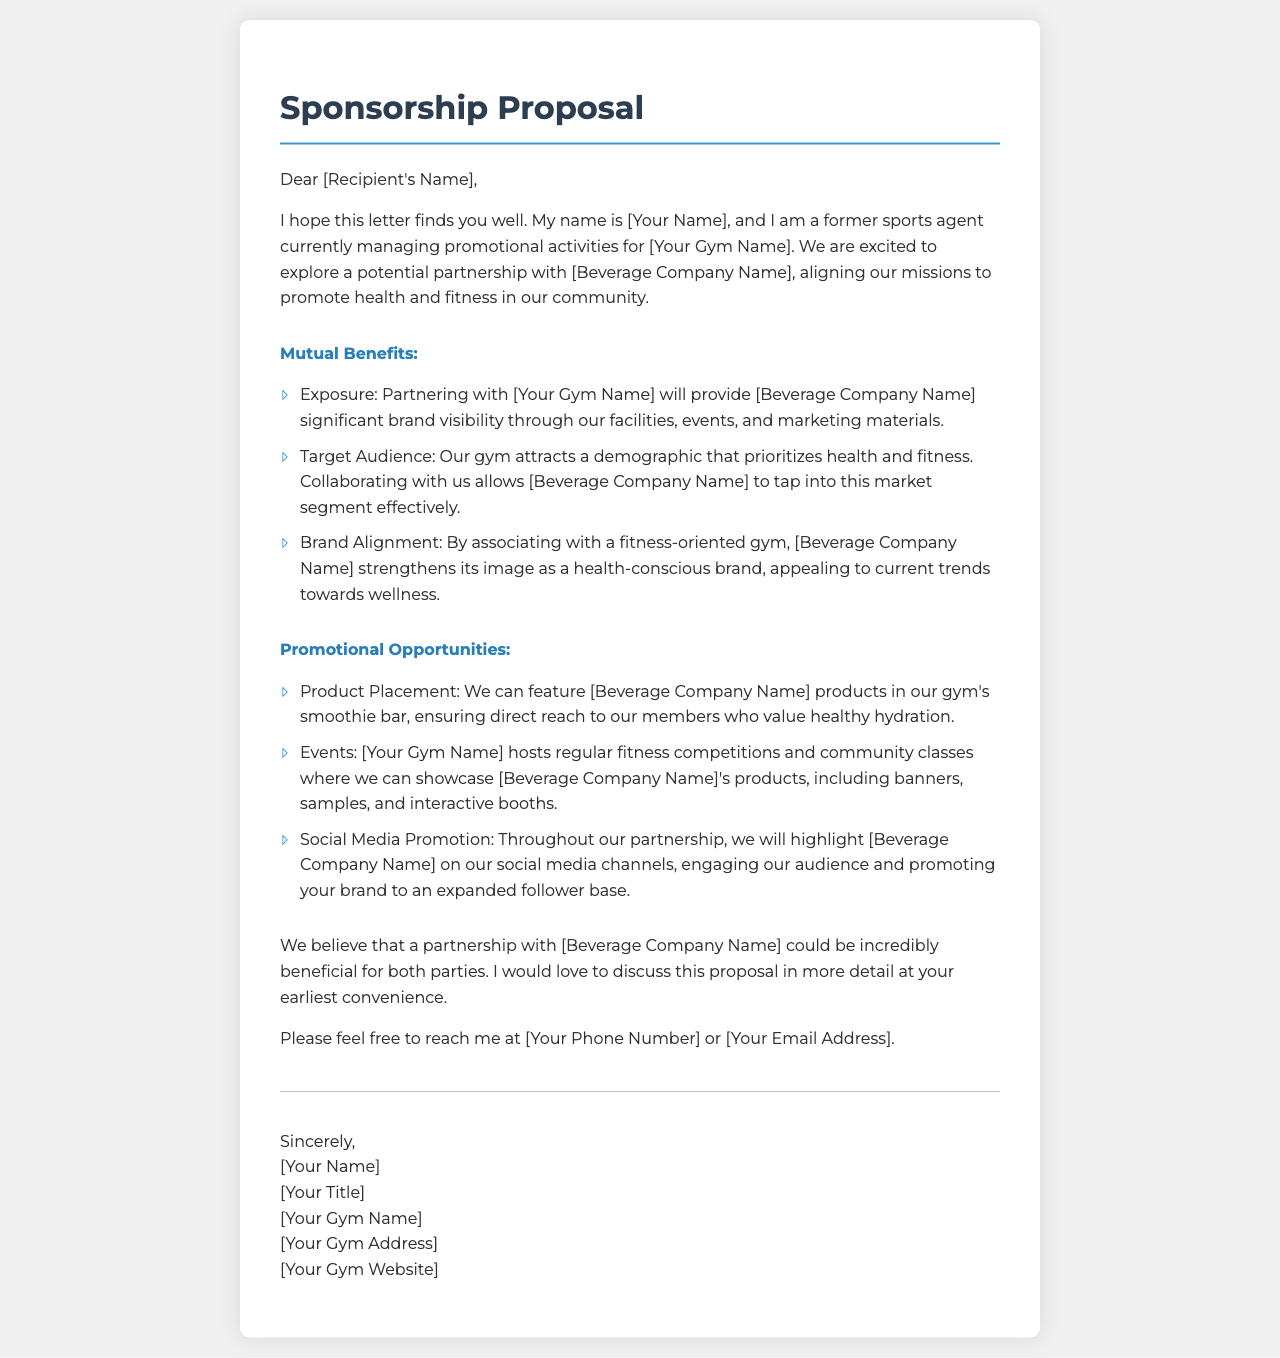What is the title of the document? The title of the document is clearly stated at the top of the letter, showcasing its purpose.
Answer: Sponsorship Proposal Who is the letter addressed to? The letter begins with a salutation addressing the recipient, specifically referring to them directly.
Answer: [Recipient's Name] What role does [Your Name] hold? The document introduces [Your Name] and outlines their professional background in relation to the proposal.
Answer: Former sports agent What is one of the mutual benefits mentioned? The letter lists multiple advantages for the beverage company, highlighting the potential for significant exposure.
Answer: Exposure How will the beverage products be featured in the gym? The proposal describes promotional opportunities, including where the beverage products could be showcased.
Answer: Smoothie bar What type of events does [Your Gym Name] host? The section on promotional opportunities touches on activities organized by the gym that can highlight the beverage brand.
Answer: Fitness competitions How can [Beverage Company Name] reach the gym's audience? The letter outlines how promotional strategies will engage with the gym's demographic.
Answer: Social Media Promotion What is the request at the end of the document? The closing of the letter suggests a follow-up action regarding a potential partnership.
Answer: Discuss this proposal in more detail What contact information is provided? The letter includes a line prompting the recipient to reach out, indicating available channels for communication.
Answer: [Your Phone Number] or [Your Email Address] 